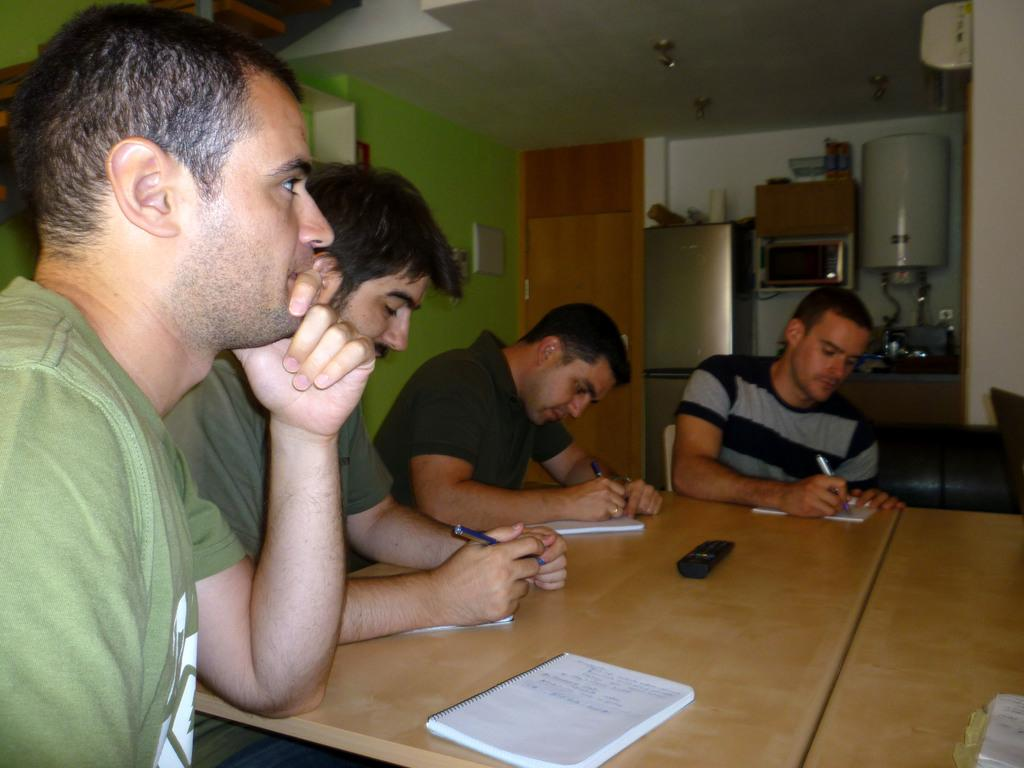How many people are in the image? There are four people in the image. What are the people doing in the image? The people are sitting around a table and writing on papers. What can be seen in the background of the image? There are shelves visible in the image. Can you describe any other objects present in the image? There are other unspecified objects present in the image. What type of game are the people playing in the image? There is no game being played in the image; the people are sitting around a table and writing on papers. What joke did the person on the left tell in the image? There is no joke being told in the image; the people are focused on writing on papers. 